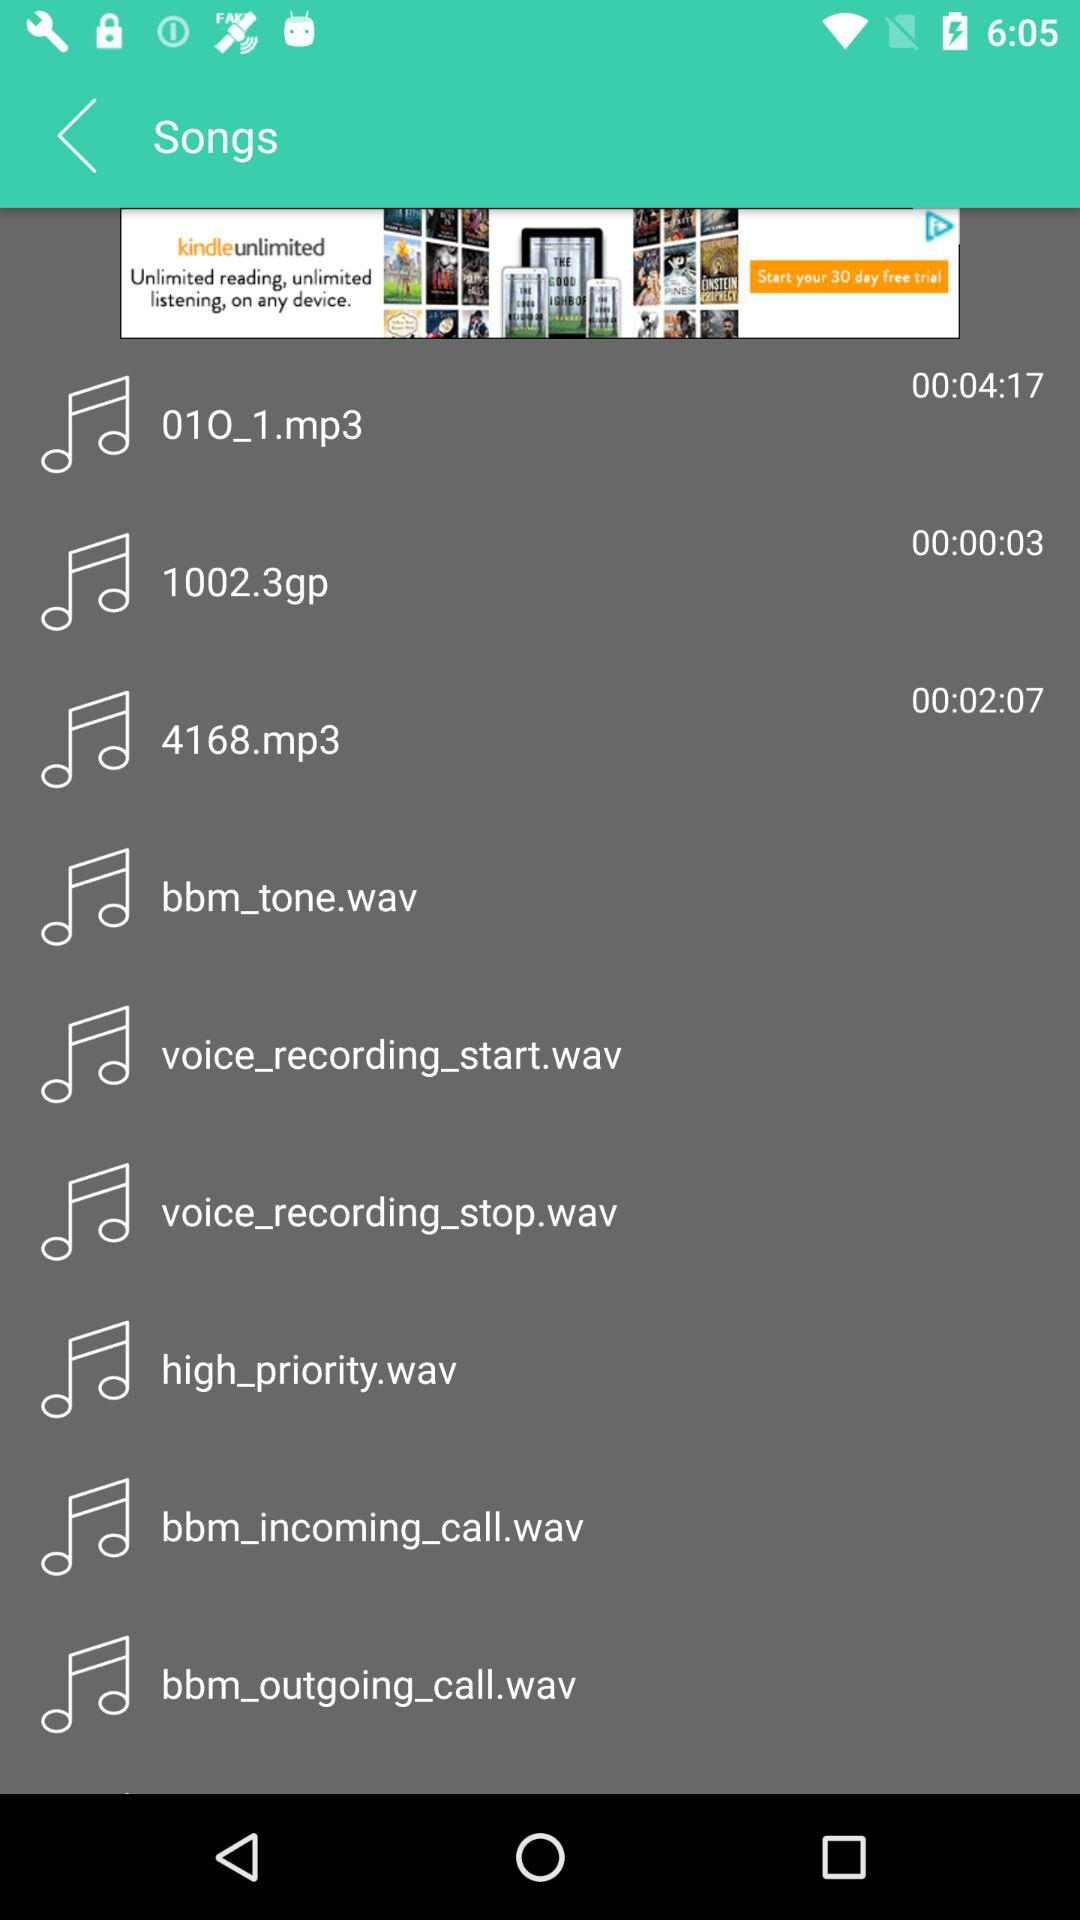Which track has a duration of 3 seconds? The track that has a duration of 3 seconds is "1002.3gp". 